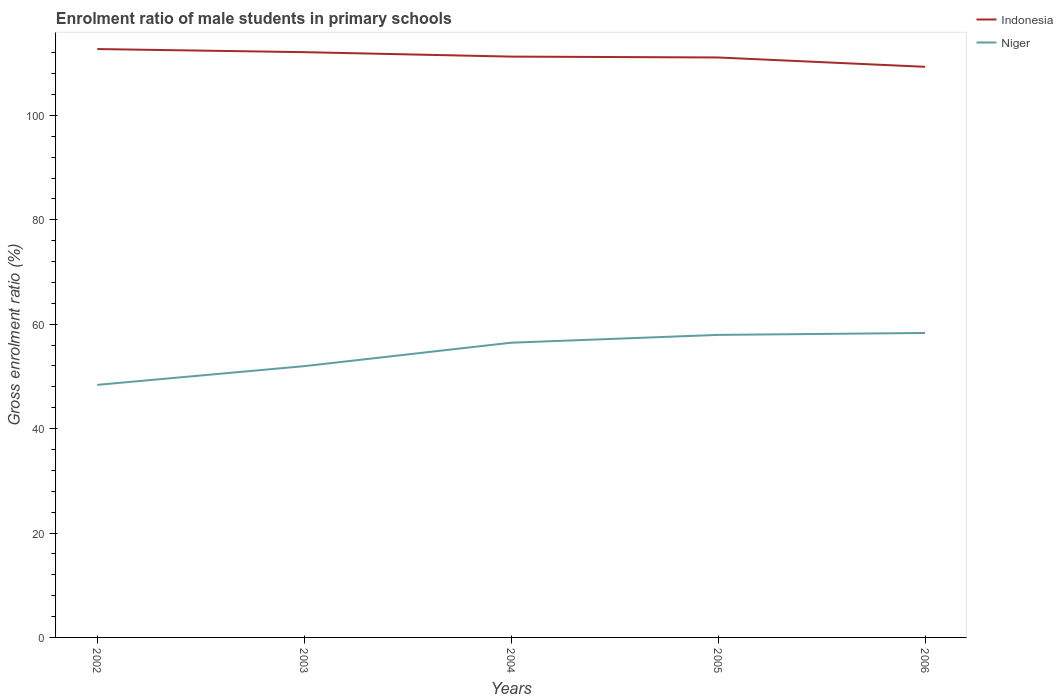Is the number of lines equal to the number of legend labels?
Offer a very short reply. Yes. Across all years, what is the maximum enrolment ratio of male students in primary schools in Indonesia?
Your answer should be compact. 109.3. In which year was the enrolment ratio of male students in primary schools in Niger maximum?
Your response must be concise. 2002. What is the total enrolment ratio of male students in primary schools in Indonesia in the graph?
Ensure brevity in your answer.  0.6. What is the difference between the highest and the second highest enrolment ratio of male students in primary schools in Niger?
Provide a succinct answer. 9.94. What is the difference between the highest and the lowest enrolment ratio of male students in primary schools in Indonesia?
Make the answer very short. 2. Are the values on the major ticks of Y-axis written in scientific E-notation?
Your answer should be compact. No. Does the graph contain any zero values?
Keep it short and to the point. No. Does the graph contain grids?
Ensure brevity in your answer.  No. Where does the legend appear in the graph?
Offer a terse response. Top right. How many legend labels are there?
Make the answer very short. 2. What is the title of the graph?
Ensure brevity in your answer.  Enrolment ratio of male students in primary schools. What is the label or title of the Y-axis?
Your answer should be compact. Gross enrolment ratio (%). What is the Gross enrolment ratio (%) of Indonesia in 2002?
Provide a succinct answer. 112.71. What is the Gross enrolment ratio (%) in Niger in 2002?
Your answer should be compact. 48.38. What is the Gross enrolment ratio (%) of Indonesia in 2003?
Ensure brevity in your answer.  112.11. What is the Gross enrolment ratio (%) of Niger in 2003?
Offer a very short reply. 51.96. What is the Gross enrolment ratio (%) of Indonesia in 2004?
Give a very brief answer. 111.26. What is the Gross enrolment ratio (%) in Niger in 2004?
Your response must be concise. 56.45. What is the Gross enrolment ratio (%) of Indonesia in 2005?
Ensure brevity in your answer.  111.09. What is the Gross enrolment ratio (%) of Niger in 2005?
Your response must be concise. 57.95. What is the Gross enrolment ratio (%) in Indonesia in 2006?
Ensure brevity in your answer.  109.3. What is the Gross enrolment ratio (%) in Niger in 2006?
Keep it short and to the point. 58.32. Across all years, what is the maximum Gross enrolment ratio (%) of Indonesia?
Provide a succinct answer. 112.71. Across all years, what is the maximum Gross enrolment ratio (%) in Niger?
Your answer should be compact. 58.32. Across all years, what is the minimum Gross enrolment ratio (%) of Indonesia?
Keep it short and to the point. 109.3. Across all years, what is the minimum Gross enrolment ratio (%) of Niger?
Make the answer very short. 48.38. What is the total Gross enrolment ratio (%) in Indonesia in the graph?
Offer a terse response. 556.46. What is the total Gross enrolment ratio (%) of Niger in the graph?
Make the answer very short. 273.07. What is the difference between the Gross enrolment ratio (%) of Indonesia in 2002 and that in 2003?
Your answer should be compact. 0.6. What is the difference between the Gross enrolment ratio (%) of Niger in 2002 and that in 2003?
Your response must be concise. -3.58. What is the difference between the Gross enrolment ratio (%) of Indonesia in 2002 and that in 2004?
Your answer should be compact. 1.45. What is the difference between the Gross enrolment ratio (%) of Niger in 2002 and that in 2004?
Your answer should be compact. -8.07. What is the difference between the Gross enrolment ratio (%) of Indonesia in 2002 and that in 2005?
Your answer should be very brief. 1.62. What is the difference between the Gross enrolment ratio (%) in Niger in 2002 and that in 2005?
Offer a terse response. -9.57. What is the difference between the Gross enrolment ratio (%) of Indonesia in 2002 and that in 2006?
Make the answer very short. 3.4. What is the difference between the Gross enrolment ratio (%) in Niger in 2002 and that in 2006?
Your answer should be very brief. -9.94. What is the difference between the Gross enrolment ratio (%) of Indonesia in 2003 and that in 2004?
Provide a short and direct response. 0.85. What is the difference between the Gross enrolment ratio (%) of Niger in 2003 and that in 2004?
Provide a short and direct response. -4.49. What is the difference between the Gross enrolment ratio (%) of Indonesia in 2003 and that in 2005?
Offer a very short reply. 1.02. What is the difference between the Gross enrolment ratio (%) of Niger in 2003 and that in 2005?
Your answer should be very brief. -5.99. What is the difference between the Gross enrolment ratio (%) in Indonesia in 2003 and that in 2006?
Keep it short and to the point. 2.81. What is the difference between the Gross enrolment ratio (%) of Niger in 2003 and that in 2006?
Make the answer very short. -6.35. What is the difference between the Gross enrolment ratio (%) of Indonesia in 2004 and that in 2005?
Ensure brevity in your answer.  0.17. What is the difference between the Gross enrolment ratio (%) in Niger in 2004 and that in 2005?
Offer a very short reply. -1.5. What is the difference between the Gross enrolment ratio (%) of Indonesia in 2004 and that in 2006?
Offer a very short reply. 1.96. What is the difference between the Gross enrolment ratio (%) of Niger in 2004 and that in 2006?
Provide a short and direct response. -1.86. What is the difference between the Gross enrolment ratio (%) in Indonesia in 2005 and that in 2006?
Offer a very short reply. 1.79. What is the difference between the Gross enrolment ratio (%) of Niger in 2005 and that in 2006?
Keep it short and to the point. -0.37. What is the difference between the Gross enrolment ratio (%) in Indonesia in 2002 and the Gross enrolment ratio (%) in Niger in 2003?
Provide a short and direct response. 60.74. What is the difference between the Gross enrolment ratio (%) of Indonesia in 2002 and the Gross enrolment ratio (%) of Niger in 2004?
Your answer should be compact. 56.25. What is the difference between the Gross enrolment ratio (%) of Indonesia in 2002 and the Gross enrolment ratio (%) of Niger in 2005?
Offer a very short reply. 54.75. What is the difference between the Gross enrolment ratio (%) of Indonesia in 2002 and the Gross enrolment ratio (%) of Niger in 2006?
Offer a very short reply. 54.39. What is the difference between the Gross enrolment ratio (%) of Indonesia in 2003 and the Gross enrolment ratio (%) of Niger in 2004?
Give a very brief answer. 55.65. What is the difference between the Gross enrolment ratio (%) of Indonesia in 2003 and the Gross enrolment ratio (%) of Niger in 2005?
Your response must be concise. 54.16. What is the difference between the Gross enrolment ratio (%) in Indonesia in 2003 and the Gross enrolment ratio (%) in Niger in 2006?
Offer a terse response. 53.79. What is the difference between the Gross enrolment ratio (%) of Indonesia in 2004 and the Gross enrolment ratio (%) of Niger in 2005?
Your response must be concise. 53.31. What is the difference between the Gross enrolment ratio (%) in Indonesia in 2004 and the Gross enrolment ratio (%) in Niger in 2006?
Offer a terse response. 52.94. What is the difference between the Gross enrolment ratio (%) of Indonesia in 2005 and the Gross enrolment ratio (%) of Niger in 2006?
Your answer should be compact. 52.77. What is the average Gross enrolment ratio (%) of Indonesia per year?
Your answer should be compact. 111.29. What is the average Gross enrolment ratio (%) of Niger per year?
Provide a succinct answer. 54.61. In the year 2002, what is the difference between the Gross enrolment ratio (%) of Indonesia and Gross enrolment ratio (%) of Niger?
Your answer should be compact. 64.32. In the year 2003, what is the difference between the Gross enrolment ratio (%) in Indonesia and Gross enrolment ratio (%) in Niger?
Provide a short and direct response. 60.14. In the year 2004, what is the difference between the Gross enrolment ratio (%) in Indonesia and Gross enrolment ratio (%) in Niger?
Your answer should be compact. 54.8. In the year 2005, what is the difference between the Gross enrolment ratio (%) of Indonesia and Gross enrolment ratio (%) of Niger?
Your answer should be very brief. 53.14. In the year 2006, what is the difference between the Gross enrolment ratio (%) of Indonesia and Gross enrolment ratio (%) of Niger?
Ensure brevity in your answer.  50.98. What is the ratio of the Gross enrolment ratio (%) of Indonesia in 2002 to that in 2003?
Your response must be concise. 1.01. What is the ratio of the Gross enrolment ratio (%) in Niger in 2002 to that in 2003?
Offer a terse response. 0.93. What is the ratio of the Gross enrolment ratio (%) in Indonesia in 2002 to that in 2004?
Provide a short and direct response. 1.01. What is the ratio of the Gross enrolment ratio (%) in Niger in 2002 to that in 2004?
Your answer should be compact. 0.86. What is the ratio of the Gross enrolment ratio (%) of Indonesia in 2002 to that in 2005?
Keep it short and to the point. 1.01. What is the ratio of the Gross enrolment ratio (%) of Niger in 2002 to that in 2005?
Provide a short and direct response. 0.83. What is the ratio of the Gross enrolment ratio (%) of Indonesia in 2002 to that in 2006?
Keep it short and to the point. 1.03. What is the ratio of the Gross enrolment ratio (%) in Niger in 2002 to that in 2006?
Make the answer very short. 0.83. What is the ratio of the Gross enrolment ratio (%) of Indonesia in 2003 to that in 2004?
Your answer should be very brief. 1.01. What is the ratio of the Gross enrolment ratio (%) of Niger in 2003 to that in 2004?
Offer a terse response. 0.92. What is the ratio of the Gross enrolment ratio (%) of Indonesia in 2003 to that in 2005?
Your response must be concise. 1.01. What is the ratio of the Gross enrolment ratio (%) in Niger in 2003 to that in 2005?
Make the answer very short. 0.9. What is the ratio of the Gross enrolment ratio (%) in Indonesia in 2003 to that in 2006?
Provide a short and direct response. 1.03. What is the ratio of the Gross enrolment ratio (%) of Niger in 2003 to that in 2006?
Offer a terse response. 0.89. What is the ratio of the Gross enrolment ratio (%) of Indonesia in 2004 to that in 2005?
Ensure brevity in your answer.  1. What is the ratio of the Gross enrolment ratio (%) in Niger in 2004 to that in 2005?
Offer a terse response. 0.97. What is the ratio of the Gross enrolment ratio (%) of Indonesia in 2004 to that in 2006?
Give a very brief answer. 1.02. What is the ratio of the Gross enrolment ratio (%) in Niger in 2004 to that in 2006?
Your answer should be compact. 0.97. What is the ratio of the Gross enrolment ratio (%) in Indonesia in 2005 to that in 2006?
Your response must be concise. 1.02. What is the difference between the highest and the second highest Gross enrolment ratio (%) in Indonesia?
Make the answer very short. 0.6. What is the difference between the highest and the second highest Gross enrolment ratio (%) of Niger?
Your answer should be compact. 0.37. What is the difference between the highest and the lowest Gross enrolment ratio (%) in Indonesia?
Make the answer very short. 3.4. What is the difference between the highest and the lowest Gross enrolment ratio (%) of Niger?
Give a very brief answer. 9.94. 